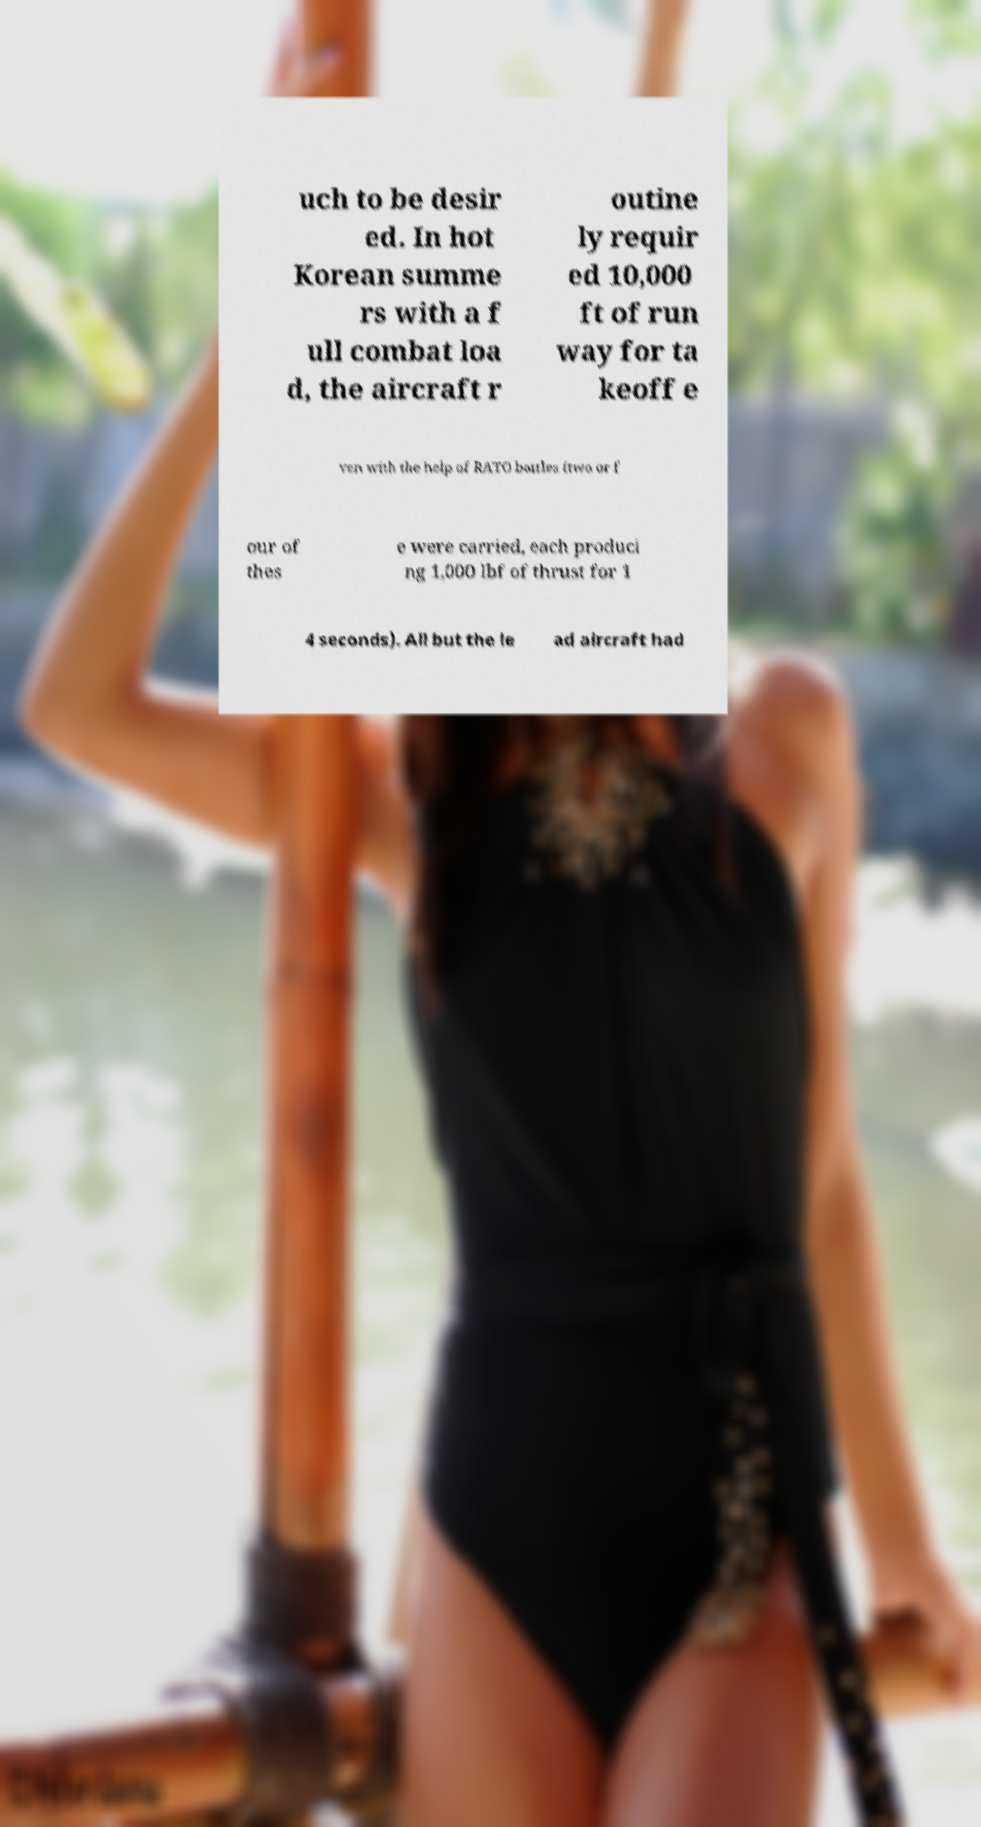There's text embedded in this image that I need extracted. Can you transcribe it verbatim? uch to be desir ed. In hot Korean summe rs with a f ull combat loa d, the aircraft r outine ly requir ed 10,000 ft of run way for ta keoff e ven with the help of RATO bottles (two or f our of thes e were carried, each produci ng 1,000 lbf of thrust for 1 4 seconds). All but the le ad aircraft had 